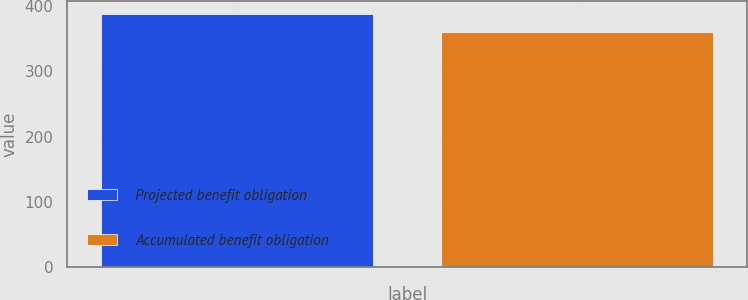Convert chart to OTSL. <chart><loc_0><loc_0><loc_500><loc_500><bar_chart><fcel>Projected benefit obligation<fcel>Accumulated benefit obligation<nl><fcel>388<fcel>360<nl></chart> 